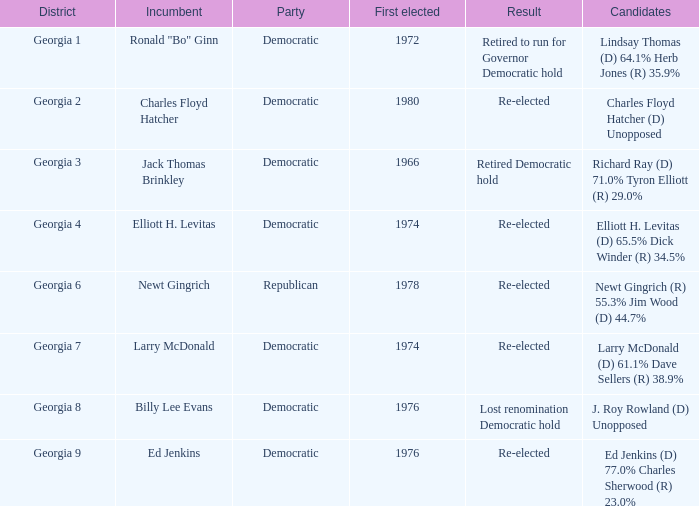Name the candidates for georgia 8 J. Roy Rowland (D) Unopposed. 